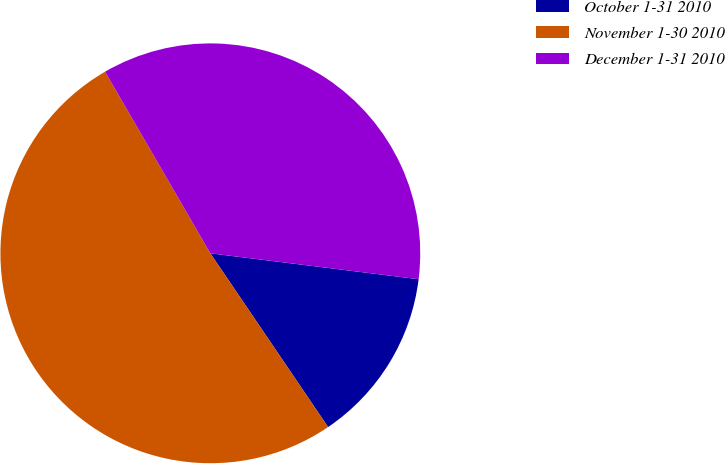<chart> <loc_0><loc_0><loc_500><loc_500><pie_chart><fcel>October 1-31 2010<fcel>November 1-30 2010<fcel>December 1-31 2010<nl><fcel>13.55%<fcel>51.12%<fcel>35.33%<nl></chart> 